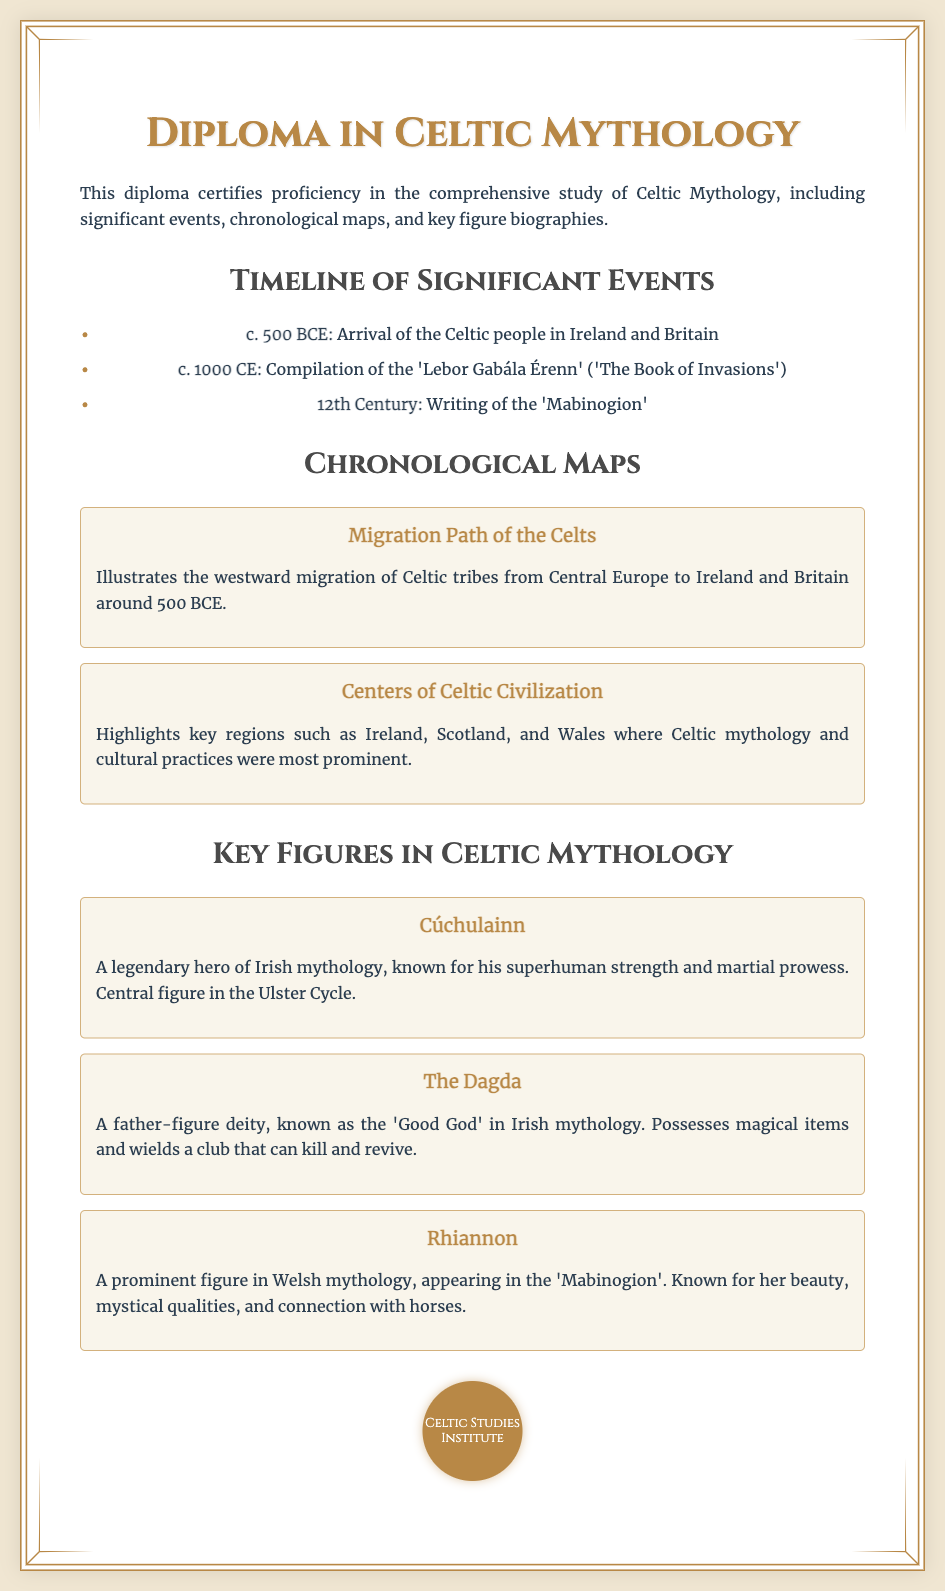What is the title of the diploma? The title of the diploma is prominently displayed at the top of the document as "Diploma in Celtic Mythology."
Answer: Diploma in Celtic Mythology When did the Celtic people arrive in Ireland and Britain? The document provides a significant event stating that the Celtic people arrived in Ireland and Britain around the year 500 BCE.
Answer: c. 500 BCE What is the 'Lebor Gabála Érenn'? It is mentioned in the timeline section as a significant event compiled around the year 1000 CE, referring to 'The Book of Invasions.'
Answer: 'The Book of Invasions' Who is Cúchulainn? Cúchulainn is introduced in the section about key figures as a legendary hero known for his superhuman strength and is a central figure in the Ulster Cycle.
Answer: A legendary hero What year does the document say the 'Mabinogion' was written? The document notes that the writing of the 'Mabinogion' took place in the 12th century.
Answer: 12th Century Which regions are highlighted as key areas of Celtic civilization? The document mentions that the highlighted key regions of Celtic civilization include Ireland, Scotland, and Wales.
Answer: Ireland, Scotland, and Wales What kind of deity is The Dagda? In the biographies, The Dagda is described as a father-figure deity known as the 'Good God' in Irish mythology.
Answer: 'Good God' What does the migration map illustrate? The document states that the migration path map illustrates the westward migration of Celtic tribes from Central Europe to Ireland and Britain around 500 BCE.
Answer: Westward migration What institution is mentioned on the seal? The seal at the bottom of the diploma displays the name of the institution related to the diploma.
Answer: Celtic Studies Institute 